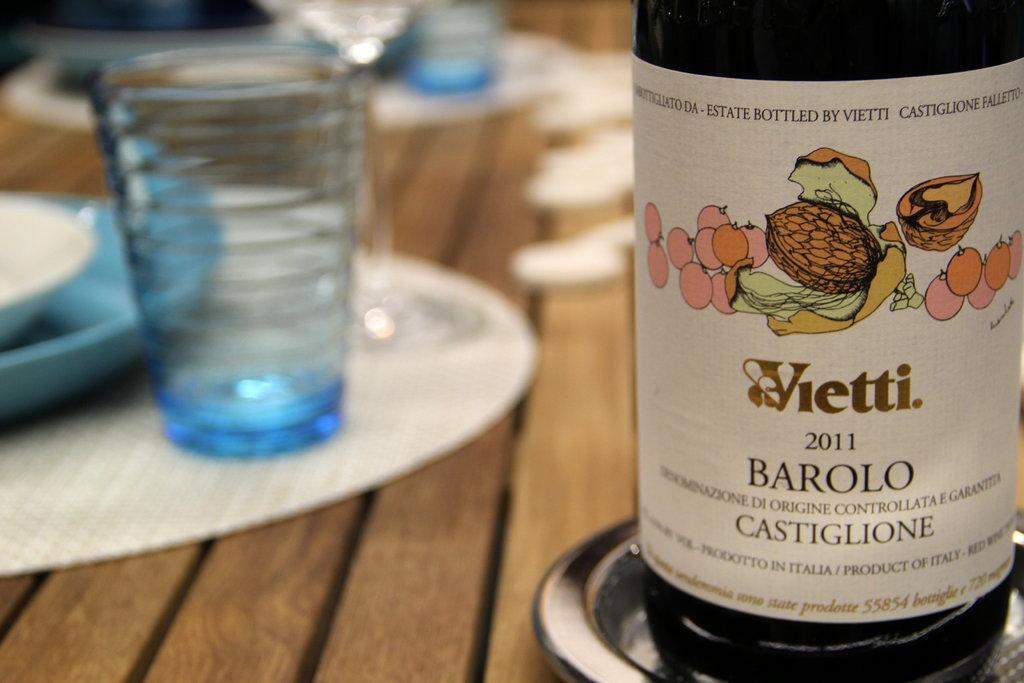Describe this image in one or two sentences. In this image I can see a bottle, a glass and few plates. 